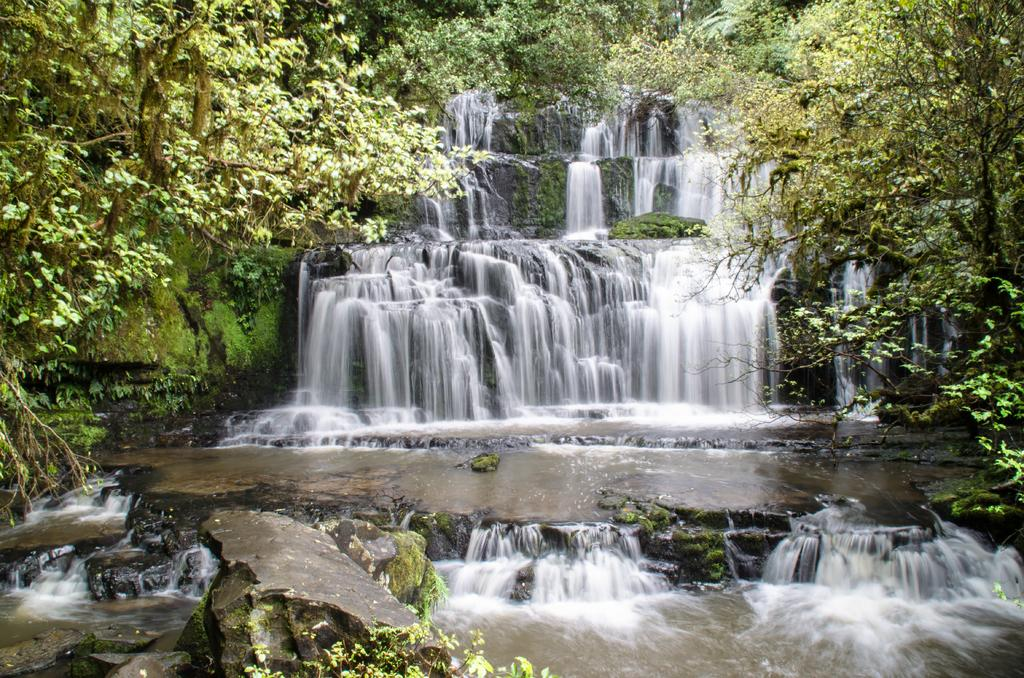What natural feature is the main subject of the image? There is a waterfall in the image. What is located at the base of the waterfall? Rocks are present at the bottom of the waterfall. What can be seen at the bottom of the waterfall? Water is visible at the bottom of the waterfall. What type of vegetation is visible in the background of the image? There are many trees in the background of the image. Where is the chessboard located in the image? There is no chessboard present in the image. What type of throne can be seen in the image? There is no throne present in the image. 